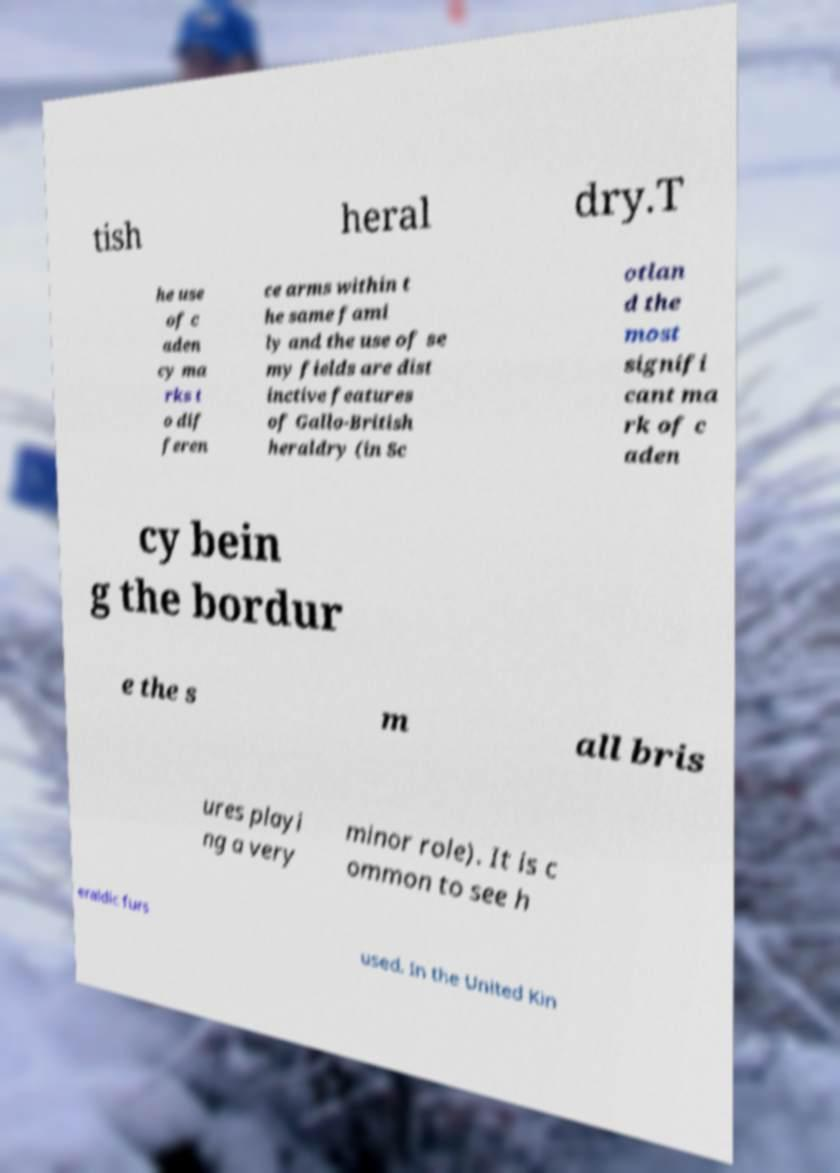Please identify and transcribe the text found in this image. tish heral dry.T he use of c aden cy ma rks t o dif feren ce arms within t he same fami ly and the use of se my fields are dist inctive features of Gallo-British heraldry (in Sc otlan d the most signifi cant ma rk of c aden cy bein g the bordur e the s m all bris ures playi ng a very minor role). It is c ommon to see h eraldic furs used. In the United Kin 